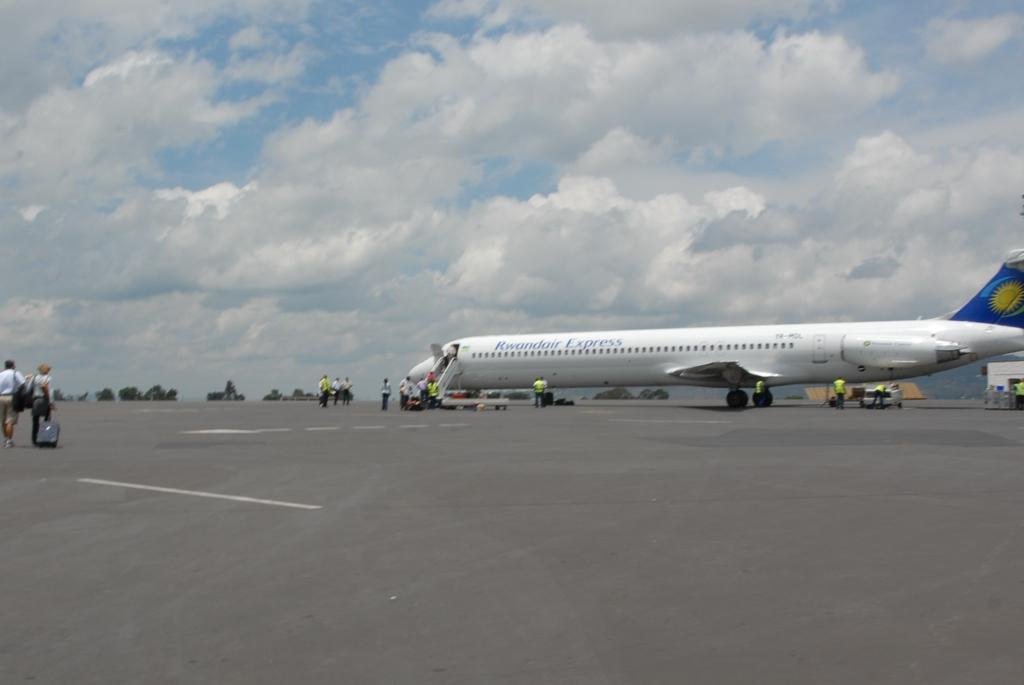What is the unusual object on the road in the image? There is an aeroplane on the road in the image. What else can be seen in the image besides the aeroplane? There are people standing in the image. What can be seen in the distance in the image? There are trees visible in the background. How would you describe the weather in the image? The sky is cloudy in the image. What type of apple is being raked into the van in the image? There is no apple or rake present in the image, nor is there a van. The image features an aeroplane on the road, people standing nearby, trees in the background, and a cloudy sky. 